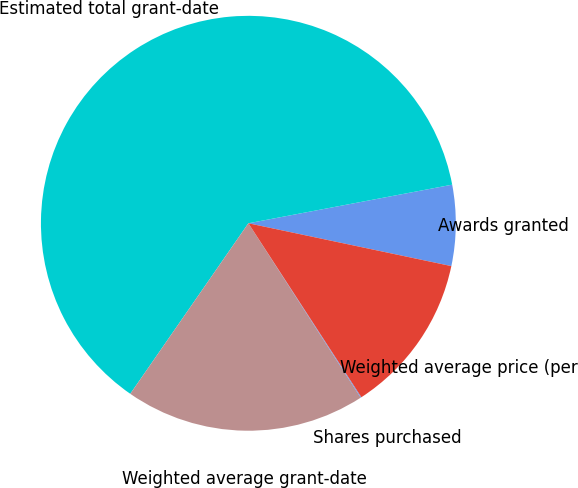Convert chart to OTSL. <chart><loc_0><loc_0><loc_500><loc_500><pie_chart><fcel>Awards granted<fcel>Estimated total grant-date<fcel>Weighted average grant-date<fcel>Shares purchased<fcel>Weighted average price (per<nl><fcel>6.29%<fcel>62.38%<fcel>18.75%<fcel>0.06%<fcel>12.52%<nl></chart> 